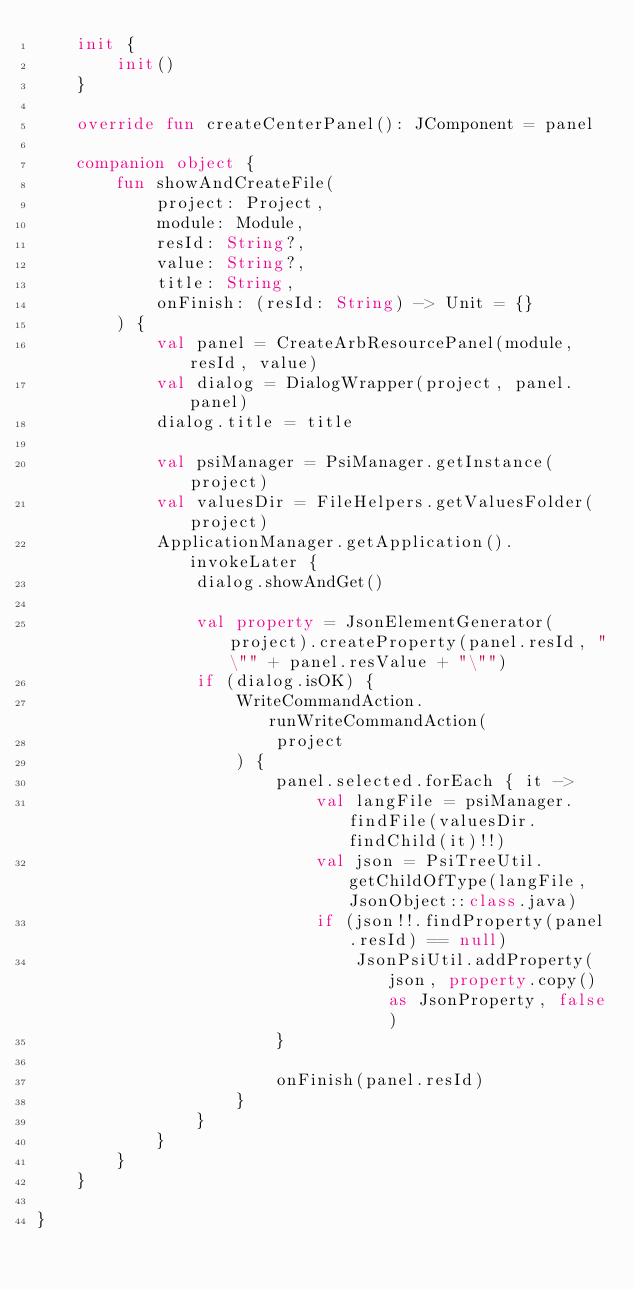<code> <loc_0><loc_0><loc_500><loc_500><_Kotlin_>    init {
        init()
    }

    override fun createCenterPanel(): JComponent = panel

    companion object {
        fun showAndCreateFile(
            project: Project,
            module: Module,
            resId: String?,
            value: String?,
            title: String,
            onFinish: (resId: String) -> Unit = {}
        ) {
            val panel = CreateArbResourcePanel(module, resId, value)
            val dialog = DialogWrapper(project, panel.panel)
            dialog.title = title

            val psiManager = PsiManager.getInstance(project)
            val valuesDir = FileHelpers.getValuesFolder(project)
            ApplicationManager.getApplication().invokeLater {
                dialog.showAndGet()

                val property = JsonElementGenerator(project).createProperty(panel.resId, "\"" + panel.resValue + "\"")
                if (dialog.isOK) {
                    WriteCommandAction.runWriteCommandAction(
                        project
                    ) {
                        panel.selected.forEach { it ->
                            val langFile = psiManager.findFile(valuesDir.findChild(it)!!)
                            val json = PsiTreeUtil.getChildOfType(langFile, JsonObject::class.java)
                            if (json!!.findProperty(panel.resId) == null)
                                JsonPsiUtil.addProperty(json, property.copy() as JsonProperty, false)
                        }

                        onFinish(panel.resId)
                    }
                }
            }
        }
    }

}</code> 